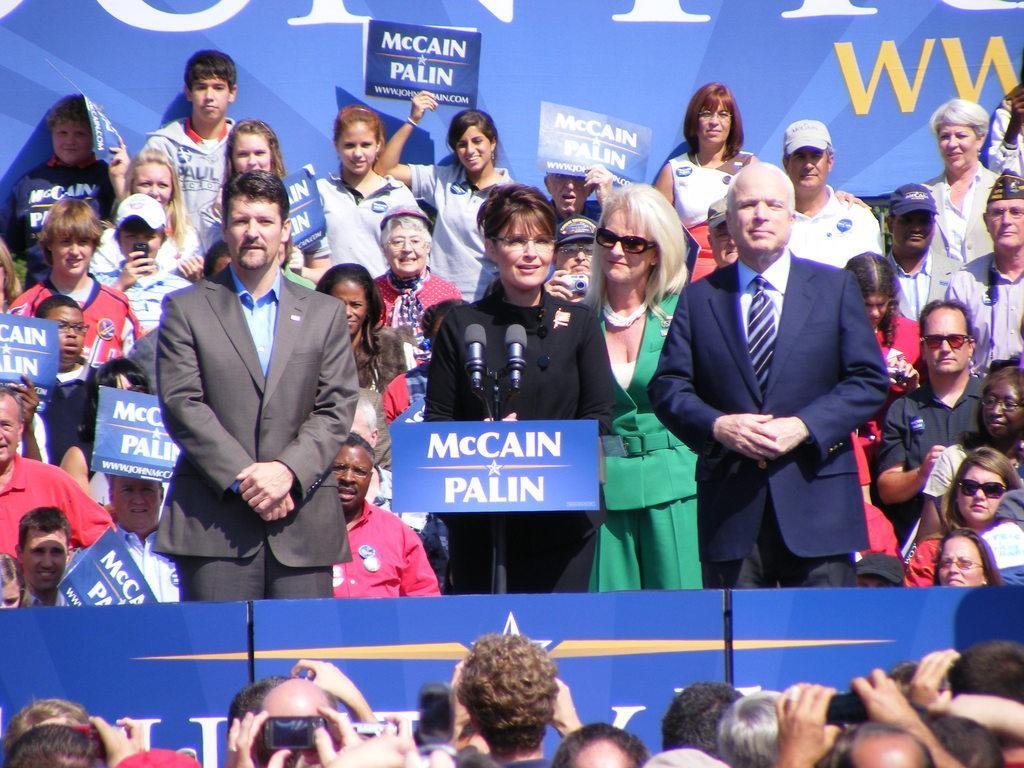Please provide a concise description of this image. In this image there are people holding the pluck cards and mobiles. In the center of the image there are three people standing in front of the mics. In the background of the image there is a banner. 